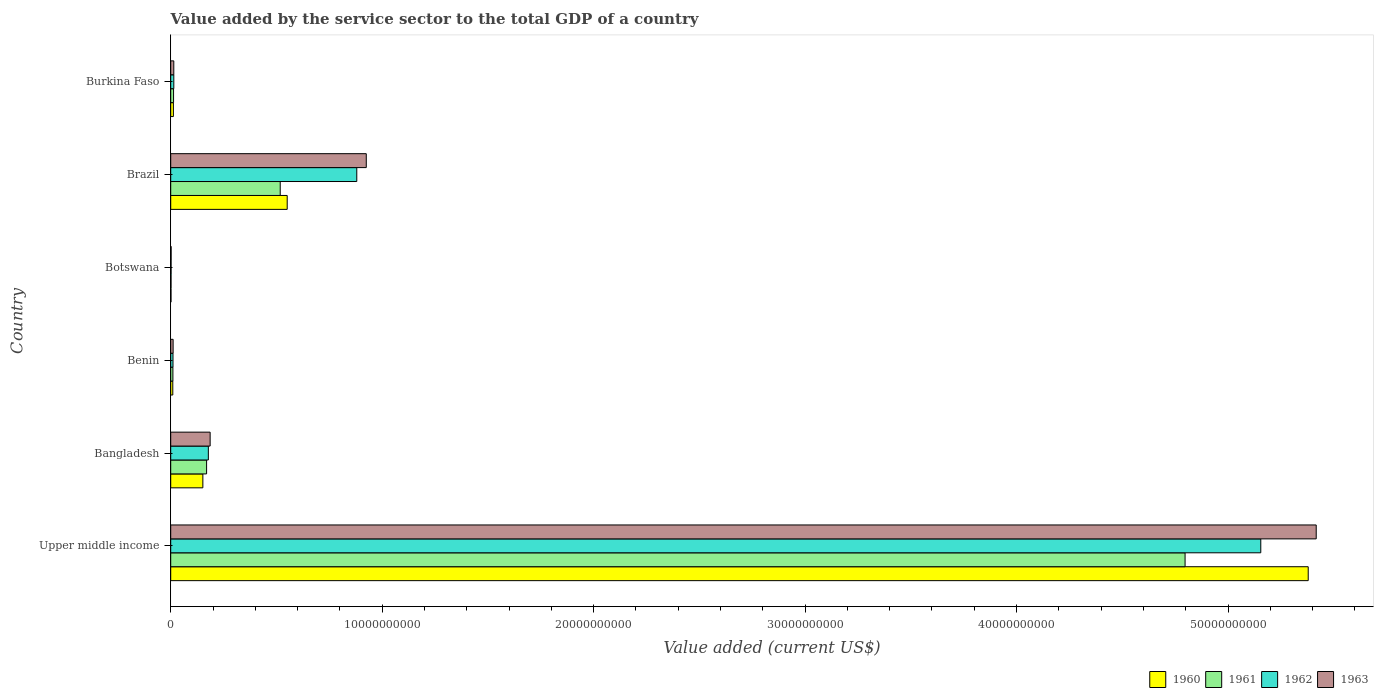How many different coloured bars are there?
Keep it short and to the point. 4. How many groups of bars are there?
Your response must be concise. 6. Are the number of bars per tick equal to the number of legend labels?
Your response must be concise. Yes. Are the number of bars on each tick of the Y-axis equal?
Offer a very short reply. Yes. What is the value added by the service sector to the total GDP in 1960 in Botswana?
Your answer should be compact. 1.31e+07. Across all countries, what is the maximum value added by the service sector to the total GDP in 1961?
Give a very brief answer. 4.80e+1. Across all countries, what is the minimum value added by the service sector to the total GDP in 1963?
Provide a short and direct response. 1.93e+07. In which country was the value added by the service sector to the total GDP in 1961 maximum?
Provide a succinct answer. Upper middle income. In which country was the value added by the service sector to the total GDP in 1961 minimum?
Provide a succinct answer. Botswana. What is the total value added by the service sector to the total GDP in 1961 in the graph?
Offer a terse response. 5.51e+1. What is the difference between the value added by the service sector to the total GDP in 1961 in Bangladesh and that in Benin?
Provide a short and direct response. 1.59e+09. What is the difference between the value added by the service sector to the total GDP in 1963 in Botswana and the value added by the service sector to the total GDP in 1962 in Burkina Faso?
Offer a very short reply. -1.27e+08. What is the average value added by the service sector to the total GDP in 1960 per country?
Offer a very short reply. 1.02e+1. What is the difference between the value added by the service sector to the total GDP in 1960 and value added by the service sector to the total GDP in 1963 in Botswana?
Make the answer very short. -6.14e+06. In how many countries, is the value added by the service sector to the total GDP in 1961 greater than 38000000000 US$?
Your answer should be compact. 1. What is the ratio of the value added by the service sector to the total GDP in 1963 in Benin to that in Burkina Faso?
Ensure brevity in your answer.  0.78. Is the value added by the service sector to the total GDP in 1963 in Brazil less than that in Burkina Faso?
Make the answer very short. No. Is the difference between the value added by the service sector to the total GDP in 1960 in Bangladesh and Burkina Faso greater than the difference between the value added by the service sector to the total GDP in 1963 in Bangladesh and Burkina Faso?
Ensure brevity in your answer.  No. What is the difference between the highest and the second highest value added by the service sector to the total GDP in 1960?
Your answer should be compact. 4.83e+1. What is the difference between the highest and the lowest value added by the service sector to the total GDP in 1961?
Give a very brief answer. 4.80e+1. In how many countries, is the value added by the service sector to the total GDP in 1961 greater than the average value added by the service sector to the total GDP in 1961 taken over all countries?
Your answer should be very brief. 1. Is the sum of the value added by the service sector to the total GDP in 1960 in Botswana and Upper middle income greater than the maximum value added by the service sector to the total GDP in 1963 across all countries?
Provide a short and direct response. No. What does the 4th bar from the top in Burkina Faso represents?
Give a very brief answer. 1960. How many bars are there?
Give a very brief answer. 24. Are the values on the major ticks of X-axis written in scientific E-notation?
Ensure brevity in your answer.  No. Where does the legend appear in the graph?
Make the answer very short. Bottom right. How many legend labels are there?
Provide a succinct answer. 4. How are the legend labels stacked?
Ensure brevity in your answer.  Horizontal. What is the title of the graph?
Ensure brevity in your answer.  Value added by the service sector to the total GDP of a country. Does "1989" appear as one of the legend labels in the graph?
Provide a succinct answer. No. What is the label or title of the X-axis?
Your answer should be compact. Value added (current US$). What is the label or title of the Y-axis?
Provide a short and direct response. Country. What is the Value added (current US$) of 1960 in Upper middle income?
Offer a very short reply. 5.38e+1. What is the Value added (current US$) in 1961 in Upper middle income?
Your answer should be very brief. 4.80e+1. What is the Value added (current US$) of 1962 in Upper middle income?
Provide a succinct answer. 5.16e+1. What is the Value added (current US$) in 1963 in Upper middle income?
Your answer should be very brief. 5.42e+1. What is the Value added (current US$) in 1960 in Bangladesh?
Your answer should be very brief. 1.52e+09. What is the Value added (current US$) in 1961 in Bangladesh?
Offer a very short reply. 1.70e+09. What is the Value added (current US$) in 1962 in Bangladesh?
Ensure brevity in your answer.  1.78e+09. What is the Value added (current US$) in 1963 in Bangladesh?
Your response must be concise. 1.86e+09. What is the Value added (current US$) of 1960 in Benin?
Your answer should be compact. 9.87e+07. What is the Value added (current US$) in 1961 in Benin?
Provide a succinct answer. 1.04e+08. What is the Value added (current US$) in 1962 in Benin?
Offer a terse response. 1.08e+08. What is the Value added (current US$) of 1963 in Benin?
Ensure brevity in your answer.  1.14e+08. What is the Value added (current US$) in 1960 in Botswana?
Keep it short and to the point. 1.31e+07. What is the Value added (current US$) of 1961 in Botswana?
Give a very brief answer. 1.51e+07. What is the Value added (current US$) of 1962 in Botswana?
Make the answer very short. 1.73e+07. What is the Value added (current US$) of 1963 in Botswana?
Your response must be concise. 1.93e+07. What is the Value added (current US$) in 1960 in Brazil?
Make the answer very short. 5.51e+09. What is the Value added (current US$) of 1961 in Brazil?
Your answer should be very brief. 5.18e+09. What is the Value added (current US$) in 1962 in Brazil?
Your answer should be very brief. 8.80e+09. What is the Value added (current US$) of 1963 in Brazil?
Give a very brief answer. 9.25e+09. What is the Value added (current US$) in 1960 in Burkina Faso?
Ensure brevity in your answer.  1.26e+08. What is the Value added (current US$) in 1961 in Burkina Faso?
Offer a terse response. 1.35e+08. What is the Value added (current US$) of 1962 in Burkina Faso?
Ensure brevity in your answer.  1.47e+08. What is the Value added (current US$) in 1963 in Burkina Faso?
Your response must be concise. 1.45e+08. Across all countries, what is the maximum Value added (current US$) of 1960?
Make the answer very short. 5.38e+1. Across all countries, what is the maximum Value added (current US$) in 1961?
Provide a short and direct response. 4.80e+1. Across all countries, what is the maximum Value added (current US$) of 1962?
Provide a short and direct response. 5.16e+1. Across all countries, what is the maximum Value added (current US$) of 1963?
Your answer should be compact. 5.42e+1. Across all countries, what is the minimum Value added (current US$) of 1960?
Make the answer very short. 1.31e+07. Across all countries, what is the minimum Value added (current US$) of 1961?
Provide a succinct answer. 1.51e+07. Across all countries, what is the minimum Value added (current US$) of 1962?
Ensure brevity in your answer.  1.73e+07. Across all countries, what is the minimum Value added (current US$) in 1963?
Offer a terse response. 1.93e+07. What is the total Value added (current US$) of 1960 in the graph?
Offer a terse response. 6.11e+1. What is the total Value added (current US$) of 1961 in the graph?
Keep it short and to the point. 5.51e+1. What is the total Value added (current US$) of 1962 in the graph?
Make the answer very short. 6.24e+1. What is the total Value added (current US$) in 1963 in the graph?
Keep it short and to the point. 6.56e+1. What is the difference between the Value added (current US$) of 1960 in Upper middle income and that in Bangladesh?
Offer a very short reply. 5.23e+1. What is the difference between the Value added (current US$) of 1961 in Upper middle income and that in Bangladesh?
Give a very brief answer. 4.63e+1. What is the difference between the Value added (current US$) of 1962 in Upper middle income and that in Bangladesh?
Your answer should be compact. 4.98e+1. What is the difference between the Value added (current US$) of 1963 in Upper middle income and that in Bangladesh?
Provide a short and direct response. 5.23e+1. What is the difference between the Value added (current US$) in 1960 in Upper middle income and that in Benin?
Your answer should be compact. 5.37e+1. What is the difference between the Value added (current US$) of 1961 in Upper middle income and that in Benin?
Your answer should be compact. 4.79e+1. What is the difference between the Value added (current US$) of 1962 in Upper middle income and that in Benin?
Keep it short and to the point. 5.14e+1. What is the difference between the Value added (current US$) of 1963 in Upper middle income and that in Benin?
Provide a succinct answer. 5.41e+1. What is the difference between the Value added (current US$) in 1960 in Upper middle income and that in Botswana?
Your answer should be compact. 5.38e+1. What is the difference between the Value added (current US$) of 1961 in Upper middle income and that in Botswana?
Offer a terse response. 4.80e+1. What is the difference between the Value added (current US$) in 1962 in Upper middle income and that in Botswana?
Make the answer very short. 5.15e+1. What is the difference between the Value added (current US$) of 1963 in Upper middle income and that in Botswana?
Your answer should be compact. 5.42e+1. What is the difference between the Value added (current US$) of 1960 in Upper middle income and that in Brazil?
Ensure brevity in your answer.  4.83e+1. What is the difference between the Value added (current US$) of 1961 in Upper middle income and that in Brazil?
Provide a succinct answer. 4.28e+1. What is the difference between the Value added (current US$) of 1962 in Upper middle income and that in Brazil?
Provide a succinct answer. 4.28e+1. What is the difference between the Value added (current US$) in 1963 in Upper middle income and that in Brazil?
Offer a terse response. 4.49e+1. What is the difference between the Value added (current US$) of 1960 in Upper middle income and that in Burkina Faso?
Offer a very short reply. 5.37e+1. What is the difference between the Value added (current US$) in 1961 in Upper middle income and that in Burkina Faso?
Offer a terse response. 4.78e+1. What is the difference between the Value added (current US$) in 1962 in Upper middle income and that in Burkina Faso?
Your answer should be compact. 5.14e+1. What is the difference between the Value added (current US$) of 1963 in Upper middle income and that in Burkina Faso?
Your answer should be very brief. 5.40e+1. What is the difference between the Value added (current US$) of 1960 in Bangladesh and that in Benin?
Your answer should be compact. 1.42e+09. What is the difference between the Value added (current US$) of 1961 in Bangladesh and that in Benin?
Provide a short and direct response. 1.59e+09. What is the difference between the Value added (current US$) in 1962 in Bangladesh and that in Benin?
Make the answer very short. 1.67e+09. What is the difference between the Value added (current US$) in 1963 in Bangladesh and that in Benin?
Give a very brief answer. 1.75e+09. What is the difference between the Value added (current US$) of 1960 in Bangladesh and that in Botswana?
Your response must be concise. 1.51e+09. What is the difference between the Value added (current US$) of 1961 in Bangladesh and that in Botswana?
Make the answer very short. 1.68e+09. What is the difference between the Value added (current US$) of 1962 in Bangladesh and that in Botswana?
Make the answer very short. 1.76e+09. What is the difference between the Value added (current US$) of 1963 in Bangladesh and that in Botswana?
Offer a terse response. 1.85e+09. What is the difference between the Value added (current US$) of 1960 in Bangladesh and that in Brazil?
Offer a very short reply. -3.99e+09. What is the difference between the Value added (current US$) in 1961 in Bangladesh and that in Brazil?
Your answer should be compact. -3.48e+09. What is the difference between the Value added (current US$) in 1962 in Bangladesh and that in Brazil?
Your answer should be very brief. -7.02e+09. What is the difference between the Value added (current US$) of 1963 in Bangladesh and that in Brazil?
Provide a short and direct response. -7.38e+09. What is the difference between the Value added (current US$) of 1960 in Bangladesh and that in Burkina Faso?
Ensure brevity in your answer.  1.39e+09. What is the difference between the Value added (current US$) of 1961 in Bangladesh and that in Burkina Faso?
Give a very brief answer. 1.56e+09. What is the difference between the Value added (current US$) in 1962 in Bangladesh and that in Burkina Faso?
Provide a succinct answer. 1.63e+09. What is the difference between the Value added (current US$) in 1963 in Bangladesh and that in Burkina Faso?
Your answer should be compact. 1.72e+09. What is the difference between the Value added (current US$) of 1960 in Benin and that in Botswana?
Make the answer very short. 8.55e+07. What is the difference between the Value added (current US$) of 1961 in Benin and that in Botswana?
Offer a very short reply. 8.86e+07. What is the difference between the Value added (current US$) of 1962 in Benin and that in Botswana?
Give a very brief answer. 9.03e+07. What is the difference between the Value added (current US$) of 1963 in Benin and that in Botswana?
Offer a terse response. 9.45e+07. What is the difference between the Value added (current US$) in 1960 in Benin and that in Brazil?
Provide a succinct answer. -5.41e+09. What is the difference between the Value added (current US$) of 1961 in Benin and that in Brazil?
Offer a terse response. -5.07e+09. What is the difference between the Value added (current US$) in 1962 in Benin and that in Brazil?
Ensure brevity in your answer.  -8.69e+09. What is the difference between the Value added (current US$) of 1963 in Benin and that in Brazil?
Offer a very short reply. -9.13e+09. What is the difference between the Value added (current US$) in 1960 in Benin and that in Burkina Faso?
Your answer should be compact. -2.78e+07. What is the difference between the Value added (current US$) of 1961 in Benin and that in Burkina Faso?
Give a very brief answer. -3.11e+07. What is the difference between the Value added (current US$) in 1962 in Benin and that in Burkina Faso?
Your answer should be very brief. -3.91e+07. What is the difference between the Value added (current US$) in 1963 in Benin and that in Burkina Faso?
Ensure brevity in your answer.  -3.15e+07. What is the difference between the Value added (current US$) in 1960 in Botswana and that in Brazil?
Provide a succinct answer. -5.50e+09. What is the difference between the Value added (current US$) in 1961 in Botswana and that in Brazil?
Offer a terse response. -5.16e+09. What is the difference between the Value added (current US$) in 1962 in Botswana and that in Brazil?
Offer a very short reply. -8.78e+09. What is the difference between the Value added (current US$) of 1963 in Botswana and that in Brazil?
Make the answer very short. -9.23e+09. What is the difference between the Value added (current US$) in 1960 in Botswana and that in Burkina Faso?
Provide a short and direct response. -1.13e+08. What is the difference between the Value added (current US$) of 1961 in Botswana and that in Burkina Faso?
Make the answer very short. -1.20e+08. What is the difference between the Value added (current US$) of 1962 in Botswana and that in Burkina Faso?
Your answer should be compact. -1.29e+08. What is the difference between the Value added (current US$) in 1963 in Botswana and that in Burkina Faso?
Make the answer very short. -1.26e+08. What is the difference between the Value added (current US$) of 1960 in Brazil and that in Burkina Faso?
Your answer should be very brief. 5.38e+09. What is the difference between the Value added (current US$) in 1961 in Brazil and that in Burkina Faso?
Keep it short and to the point. 5.04e+09. What is the difference between the Value added (current US$) in 1962 in Brazil and that in Burkina Faso?
Provide a short and direct response. 8.65e+09. What is the difference between the Value added (current US$) in 1963 in Brazil and that in Burkina Faso?
Make the answer very short. 9.10e+09. What is the difference between the Value added (current US$) of 1960 in Upper middle income and the Value added (current US$) of 1961 in Bangladesh?
Provide a short and direct response. 5.21e+1. What is the difference between the Value added (current US$) in 1960 in Upper middle income and the Value added (current US$) in 1962 in Bangladesh?
Your answer should be very brief. 5.20e+1. What is the difference between the Value added (current US$) in 1960 in Upper middle income and the Value added (current US$) in 1963 in Bangladesh?
Provide a succinct answer. 5.19e+1. What is the difference between the Value added (current US$) in 1961 in Upper middle income and the Value added (current US$) in 1962 in Bangladesh?
Give a very brief answer. 4.62e+1. What is the difference between the Value added (current US$) in 1961 in Upper middle income and the Value added (current US$) in 1963 in Bangladesh?
Offer a terse response. 4.61e+1. What is the difference between the Value added (current US$) in 1962 in Upper middle income and the Value added (current US$) in 1963 in Bangladesh?
Offer a terse response. 4.97e+1. What is the difference between the Value added (current US$) in 1960 in Upper middle income and the Value added (current US$) in 1961 in Benin?
Make the answer very short. 5.37e+1. What is the difference between the Value added (current US$) of 1960 in Upper middle income and the Value added (current US$) of 1962 in Benin?
Offer a very short reply. 5.37e+1. What is the difference between the Value added (current US$) of 1960 in Upper middle income and the Value added (current US$) of 1963 in Benin?
Your answer should be very brief. 5.37e+1. What is the difference between the Value added (current US$) of 1961 in Upper middle income and the Value added (current US$) of 1962 in Benin?
Offer a very short reply. 4.79e+1. What is the difference between the Value added (current US$) of 1961 in Upper middle income and the Value added (current US$) of 1963 in Benin?
Offer a very short reply. 4.79e+1. What is the difference between the Value added (current US$) of 1962 in Upper middle income and the Value added (current US$) of 1963 in Benin?
Keep it short and to the point. 5.14e+1. What is the difference between the Value added (current US$) of 1960 in Upper middle income and the Value added (current US$) of 1961 in Botswana?
Provide a succinct answer. 5.38e+1. What is the difference between the Value added (current US$) of 1960 in Upper middle income and the Value added (current US$) of 1962 in Botswana?
Make the answer very short. 5.38e+1. What is the difference between the Value added (current US$) of 1960 in Upper middle income and the Value added (current US$) of 1963 in Botswana?
Give a very brief answer. 5.38e+1. What is the difference between the Value added (current US$) of 1961 in Upper middle income and the Value added (current US$) of 1962 in Botswana?
Offer a very short reply. 4.80e+1. What is the difference between the Value added (current US$) of 1961 in Upper middle income and the Value added (current US$) of 1963 in Botswana?
Make the answer very short. 4.80e+1. What is the difference between the Value added (current US$) of 1962 in Upper middle income and the Value added (current US$) of 1963 in Botswana?
Your answer should be compact. 5.15e+1. What is the difference between the Value added (current US$) in 1960 in Upper middle income and the Value added (current US$) in 1961 in Brazil?
Your response must be concise. 4.86e+1. What is the difference between the Value added (current US$) in 1960 in Upper middle income and the Value added (current US$) in 1962 in Brazil?
Your answer should be very brief. 4.50e+1. What is the difference between the Value added (current US$) in 1960 in Upper middle income and the Value added (current US$) in 1963 in Brazil?
Offer a very short reply. 4.45e+1. What is the difference between the Value added (current US$) in 1961 in Upper middle income and the Value added (current US$) in 1962 in Brazil?
Your answer should be very brief. 3.92e+1. What is the difference between the Value added (current US$) in 1961 in Upper middle income and the Value added (current US$) in 1963 in Brazil?
Provide a short and direct response. 3.87e+1. What is the difference between the Value added (current US$) in 1962 in Upper middle income and the Value added (current US$) in 1963 in Brazil?
Offer a very short reply. 4.23e+1. What is the difference between the Value added (current US$) of 1960 in Upper middle income and the Value added (current US$) of 1961 in Burkina Faso?
Ensure brevity in your answer.  5.37e+1. What is the difference between the Value added (current US$) in 1960 in Upper middle income and the Value added (current US$) in 1962 in Burkina Faso?
Offer a very short reply. 5.36e+1. What is the difference between the Value added (current US$) in 1960 in Upper middle income and the Value added (current US$) in 1963 in Burkina Faso?
Offer a very short reply. 5.36e+1. What is the difference between the Value added (current US$) of 1961 in Upper middle income and the Value added (current US$) of 1962 in Burkina Faso?
Give a very brief answer. 4.78e+1. What is the difference between the Value added (current US$) in 1961 in Upper middle income and the Value added (current US$) in 1963 in Burkina Faso?
Your response must be concise. 4.78e+1. What is the difference between the Value added (current US$) of 1962 in Upper middle income and the Value added (current US$) of 1963 in Burkina Faso?
Your answer should be compact. 5.14e+1. What is the difference between the Value added (current US$) in 1960 in Bangladesh and the Value added (current US$) in 1961 in Benin?
Offer a very short reply. 1.42e+09. What is the difference between the Value added (current US$) of 1960 in Bangladesh and the Value added (current US$) of 1962 in Benin?
Your response must be concise. 1.41e+09. What is the difference between the Value added (current US$) in 1960 in Bangladesh and the Value added (current US$) in 1963 in Benin?
Give a very brief answer. 1.41e+09. What is the difference between the Value added (current US$) in 1961 in Bangladesh and the Value added (current US$) in 1962 in Benin?
Offer a very short reply. 1.59e+09. What is the difference between the Value added (current US$) in 1961 in Bangladesh and the Value added (current US$) in 1963 in Benin?
Offer a very short reply. 1.58e+09. What is the difference between the Value added (current US$) in 1962 in Bangladesh and the Value added (current US$) in 1963 in Benin?
Keep it short and to the point. 1.67e+09. What is the difference between the Value added (current US$) of 1960 in Bangladesh and the Value added (current US$) of 1961 in Botswana?
Provide a succinct answer. 1.50e+09. What is the difference between the Value added (current US$) of 1960 in Bangladesh and the Value added (current US$) of 1962 in Botswana?
Give a very brief answer. 1.50e+09. What is the difference between the Value added (current US$) in 1960 in Bangladesh and the Value added (current US$) in 1963 in Botswana?
Your answer should be very brief. 1.50e+09. What is the difference between the Value added (current US$) of 1961 in Bangladesh and the Value added (current US$) of 1962 in Botswana?
Ensure brevity in your answer.  1.68e+09. What is the difference between the Value added (current US$) of 1961 in Bangladesh and the Value added (current US$) of 1963 in Botswana?
Provide a succinct answer. 1.68e+09. What is the difference between the Value added (current US$) in 1962 in Bangladesh and the Value added (current US$) in 1963 in Botswana?
Offer a terse response. 1.76e+09. What is the difference between the Value added (current US$) of 1960 in Bangladesh and the Value added (current US$) of 1961 in Brazil?
Ensure brevity in your answer.  -3.66e+09. What is the difference between the Value added (current US$) in 1960 in Bangladesh and the Value added (current US$) in 1962 in Brazil?
Your answer should be compact. -7.28e+09. What is the difference between the Value added (current US$) of 1960 in Bangladesh and the Value added (current US$) of 1963 in Brazil?
Your response must be concise. -7.73e+09. What is the difference between the Value added (current US$) of 1961 in Bangladesh and the Value added (current US$) of 1962 in Brazil?
Give a very brief answer. -7.10e+09. What is the difference between the Value added (current US$) of 1961 in Bangladesh and the Value added (current US$) of 1963 in Brazil?
Give a very brief answer. -7.55e+09. What is the difference between the Value added (current US$) of 1962 in Bangladesh and the Value added (current US$) of 1963 in Brazil?
Your answer should be compact. -7.47e+09. What is the difference between the Value added (current US$) in 1960 in Bangladesh and the Value added (current US$) in 1961 in Burkina Faso?
Keep it short and to the point. 1.39e+09. What is the difference between the Value added (current US$) in 1960 in Bangladesh and the Value added (current US$) in 1962 in Burkina Faso?
Provide a succinct answer. 1.37e+09. What is the difference between the Value added (current US$) in 1960 in Bangladesh and the Value added (current US$) in 1963 in Burkina Faso?
Your answer should be very brief. 1.37e+09. What is the difference between the Value added (current US$) of 1961 in Bangladesh and the Value added (current US$) of 1962 in Burkina Faso?
Ensure brevity in your answer.  1.55e+09. What is the difference between the Value added (current US$) of 1961 in Bangladesh and the Value added (current US$) of 1963 in Burkina Faso?
Give a very brief answer. 1.55e+09. What is the difference between the Value added (current US$) of 1962 in Bangladesh and the Value added (current US$) of 1963 in Burkina Faso?
Ensure brevity in your answer.  1.63e+09. What is the difference between the Value added (current US$) of 1960 in Benin and the Value added (current US$) of 1961 in Botswana?
Provide a succinct answer. 8.36e+07. What is the difference between the Value added (current US$) in 1960 in Benin and the Value added (current US$) in 1962 in Botswana?
Your response must be concise. 8.14e+07. What is the difference between the Value added (current US$) of 1960 in Benin and the Value added (current US$) of 1963 in Botswana?
Offer a very short reply. 7.94e+07. What is the difference between the Value added (current US$) in 1961 in Benin and the Value added (current US$) in 1962 in Botswana?
Your answer should be very brief. 8.64e+07. What is the difference between the Value added (current US$) in 1961 in Benin and the Value added (current US$) in 1963 in Botswana?
Offer a terse response. 8.44e+07. What is the difference between the Value added (current US$) of 1962 in Benin and the Value added (current US$) of 1963 in Botswana?
Ensure brevity in your answer.  8.83e+07. What is the difference between the Value added (current US$) in 1960 in Benin and the Value added (current US$) in 1961 in Brazil?
Ensure brevity in your answer.  -5.08e+09. What is the difference between the Value added (current US$) of 1960 in Benin and the Value added (current US$) of 1962 in Brazil?
Make the answer very short. -8.70e+09. What is the difference between the Value added (current US$) in 1960 in Benin and the Value added (current US$) in 1963 in Brazil?
Offer a very short reply. -9.15e+09. What is the difference between the Value added (current US$) in 1961 in Benin and the Value added (current US$) in 1962 in Brazil?
Ensure brevity in your answer.  -8.70e+09. What is the difference between the Value added (current US$) in 1961 in Benin and the Value added (current US$) in 1963 in Brazil?
Provide a short and direct response. -9.14e+09. What is the difference between the Value added (current US$) in 1962 in Benin and the Value added (current US$) in 1963 in Brazil?
Give a very brief answer. -9.14e+09. What is the difference between the Value added (current US$) in 1960 in Benin and the Value added (current US$) in 1961 in Burkina Faso?
Your answer should be very brief. -3.61e+07. What is the difference between the Value added (current US$) in 1960 in Benin and the Value added (current US$) in 1962 in Burkina Faso?
Ensure brevity in your answer.  -4.81e+07. What is the difference between the Value added (current US$) of 1960 in Benin and the Value added (current US$) of 1963 in Burkina Faso?
Your answer should be very brief. -4.67e+07. What is the difference between the Value added (current US$) in 1961 in Benin and the Value added (current US$) in 1962 in Burkina Faso?
Your response must be concise. -4.30e+07. What is the difference between the Value added (current US$) of 1961 in Benin and the Value added (current US$) of 1963 in Burkina Faso?
Ensure brevity in your answer.  -4.16e+07. What is the difference between the Value added (current US$) in 1962 in Benin and the Value added (current US$) in 1963 in Burkina Faso?
Keep it short and to the point. -3.77e+07. What is the difference between the Value added (current US$) in 1960 in Botswana and the Value added (current US$) in 1961 in Brazil?
Keep it short and to the point. -5.17e+09. What is the difference between the Value added (current US$) in 1960 in Botswana and the Value added (current US$) in 1962 in Brazil?
Keep it short and to the point. -8.79e+09. What is the difference between the Value added (current US$) in 1960 in Botswana and the Value added (current US$) in 1963 in Brazil?
Ensure brevity in your answer.  -9.24e+09. What is the difference between the Value added (current US$) of 1961 in Botswana and the Value added (current US$) of 1962 in Brazil?
Give a very brief answer. -8.78e+09. What is the difference between the Value added (current US$) in 1961 in Botswana and the Value added (current US$) in 1963 in Brazil?
Your answer should be very brief. -9.23e+09. What is the difference between the Value added (current US$) of 1962 in Botswana and the Value added (current US$) of 1963 in Brazil?
Your answer should be compact. -9.23e+09. What is the difference between the Value added (current US$) in 1960 in Botswana and the Value added (current US$) in 1961 in Burkina Faso?
Ensure brevity in your answer.  -1.22e+08. What is the difference between the Value added (current US$) in 1960 in Botswana and the Value added (current US$) in 1962 in Burkina Faso?
Offer a terse response. -1.34e+08. What is the difference between the Value added (current US$) of 1960 in Botswana and the Value added (current US$) of 1963 in Burkina Faso?
Offer a very short reply. -1.32e+08. What is the difference between the Value added (current US$) of 1961 in Botswana and the Value added (current US$) of 1962 in Burkina Faso?
Your answer should be very brief. -1.32e+08. What is the difference between the Value added (current US$) of 1961 in Botswana and the Value added (current US$) of 1963 in Burkina Faso?
Ensure brevity in your answer.  -1.30e+08. What is the difference between the Value added (current US$) of 1962 in Botswana and the Value added (current US$) of 1963 in Burkina Faso?
Your answer should be compact. -1.28e+08. What is the difference between the Value added (current US$) of 1960 in Brazil and the Value added (current US$) of 1961 in Burkina Faso?
Ensure brevity in your answer.  5.37e+09. What is the difference between the Value added (current US$) in 1960 in Brazil and the Value added (current US$) in 1962 in Burkina Faso?
Ensure brevity in your answer.  5.36e+09. What is the difference between the Value added (current US$) in 1960 in Brazil and the Value added (current US$) in 1963 in Burkina Faso?
Give a very brief answer. 5.36e+09. What is the difference between the Value added (current US$) in 1961 in Brazil and the Value added (current US$) in 1962 in Burkina Faso?
Make the answer very short. 5.03e+09. What is the difference between the Value added (current US$) of 1961 in Brazil and the Value added (current US$) of 1963 in Burkina Faso?
Your answer should be very brief. 5.03e+09. What is the difference between the Value added (current US$) of 1962 in Brazil and the Value added (current US$) of 1963 in Burkina Faso?
Give a very brief answer. 8.65e+09. What is the average Value added (current US$) of 1960 per country?
Offer a very short reply. 1.02e+1. What is the average Value added (current US$) in 1961 per country?
Your answer should be very brief. 9.18e+09. What is the average Value added (current US$) of 1962 per country?
Offer a terse response. 1.04e+1. What is the average Value added (current US$) in 1963 per country?
Give a very brief answer. 1.09e+1. What is the difference between the Value added (current US$) of 1960 and Value added (current US$) of 1961 in Upper middle income?
Your answer should be very brief. 5.82e+09. What is the difference between the Value added (current US$) of 1960 and Value added (current US$) of 1962 in Upper middle income?
Keep it short and to the point. 2.24e+09. What is the difference between the Value added (current US$) of 1960 and Value added (current US$) of 1963 in Upper middle income?
Ensure brevity in your answer.  -3.78e+08. What is the difference between the Value added (current US$) in 1961 and Value added (current US$) in 1962 in Upper middle income?
Offer a terse response. -3.58e+09. What is the difference between the Value added (current US$) of 1961 and Value added (current US$) of 1963 in Upper middle income?
Offer a very short reply. -6.20e+09. What is the difference between the Value added (current US$) in 1962 and Value added (current US$) in 1963 in Upper middle income?
Give a very brief answer. -2.62e+09. What is the difference between the Value added (current US$) in 1960 and Value added (current US$) in 1961 in Bangladesh?
Offer a terse response. -1.77e+08. What is the difference between the Value added (current US$) in 1960 and Value added (current US$) in 1962 in Bangladesh?
Keep it short and to the point. -2.60e+08. What is the difference between the Value added (current US$) in 1960 and Value added (current US$) in 1963 in Bangladesh?
Give a very brief answer. -3.45e+08. What is the difference between the Value added (current US$) in 1961 and Value added (current US$) in 1962 in Bangladesh?
Offer a very short reply. -8.27e+07. What is the difference between the Value added (current US$) of 1961 and Value added (current US$) of 1963 in Bangladesh?
Offer a terse response. -1.68e+08. What is the difference between the Value added (current US$) of 1962 and Value added (current US$) of 1963 in Bangladesh?
Offer a terse response. -8.50e+07. What is the difference between the Value added (current US$) of 1960 and Value added (current US$) of 1961 in Benin?
Offer a terse response. -5.02e+06. What is the difference between the Value added (current US$) in 1960 and Value added (current US$) in 1962 in Benin?
Provide a short and direct response. -8.92e+06. What is the difference between the Value added (current US$) of 1960 and Value added (current US$) of 1963 in Benin?
Offer a terse response. -1.51e+07. What is the difference between the Value added (current US$) of 1961 and Value added (current US$) of 1962 in Benin?
Provide a succinct answer. -3.90e+06. What is the difference between the Value added (current US$) in 1961 and Value added (current US$) in 1963 in Benin?
Offer a terse response. -1.01e+07. What is the difference between the Value added (current US$) of 1962 and Value added (current US$) of 1963 in Benin?
Your answer should be compact. -6.21e+06. What is the difference between the Value added (current US$) in 1960 and Value added (current US$) in 1961 in Botswana?
Your answer should be compact. -1.99e+06. What is the difference between the Value added (current US$) of 1960 and Value added (current US$) of 1962 in Botswana?
Keep it short and to the point. -4.17e+06. What is the difference between the Value added (current US$) in 1960 and Value added (current US$) in 1963 in Botswana?
Ensure brevity in your answer.  -6.14e+06. What is the difference between the Value added (current US$) of 1961 and Value added (current US$) of 1962 in Botswana?
Offer a terse response. -2.18e+06. What is the difference between the Value added (current US$) of 1961 and Value added (current US$) of 1963 in Botswana?
Provide a short and direct response. -4.15e+06. What is the difference between the Value added (current US$) in 1962 and Value added (current US$) in 1963 in Botswana?
Provide a succinct answer. -1.97e+06. What is the difference between the Value added (current US$) in 1960 and Value added (current US$) in 1961 in Brazil?
Provide a succinct answer. 3.31e+08. What is the difference between the Value added (current US$) of 1960 and Value added (current US$) of 1962 in Brazil?
Your answer should be compact. -3.29e+09. What is the difference between the Value added (current US$) in 1960 and Value added (current US$) in 1963 in Brazil?
Your response must be concise. -3.74e+09. What is the difference between the Value added (current US$) of 1961 and Value added (current US$) of 1962 in Brazil?
Provide a short and direct response. -3.62e+09. What is the difference between the Value added (current US$) of 1961 and Value added (current US$) of 1963 in Brazil?
Your response must be concise. -4.07e+09. What is the difference between the Value added (current US$) of 1962 and Value added (current US$) of 1963 in Brazil?
Keep it short and to the point. -4.49e+08. What is the difference between the Value added (current US$) in 1960 and Value added (current US$) in 1961 in Burkina Faso?
Your answer should be compact. -8.32e+06. What is the difference between the Value added (current US$) in 1960 and Value added (current US$) in 1962 in Burkina Faso?
Offer a terse response. -2.03e+07. What is the difference between the Value added (current US$) of 1960 and Value added (current US$) of 1963 in Burkina Faso?
Your response must be concise. -1.89e+07. What is the difference between the Value added (current US$) of 1961 and Value added (current US$) of 1962 in Burkina Faso?
Offer a terse response. -1.19e+07. What is the difference between the Value added (current US$) of 1961 and Value added (current US$) of 1963 in Burkina Faso?
Provide a short and direct response. -1.06e+07. What is the difference between the Value added (current US$) of 1962 and Value added (current US$) of 1963 in Burkina Faso?
Your answer should be very brief. 1.38e+06. What is the ratio of the Value added (current US$) in 1960 in Upper middle income to that in Bangladesh?
Give a very brief answer. 35.4. What is the ratio of the Value added (current US$) in 1961 in Upper middle income to that in Bangladesh?
Provide a succinct answer. 28.27. What is the ratio of the Value added (current US$) in 1962 in Upper middle income to that in Bangladesh?
Keep it short and to the point. 28.97. What is the ratio of the Value added (current US$) in 1963 in Upper middle income to that in Bangladesh?
Ensure brevity in your answer.  29.06. What is the ratio of the Value added (current US$) of 1960 in Upper middle income to that in Benin?
Keep it short and to the point. 545.27. What is the ratio of the Value added (current US$) in 1961 in Upper middle income to that in Benin?
Give a very brief answer. 462.69. What is the ratio of the Value added (current US$) in 1962 in Upper middle income to that in Benin?
Provide a short and direct response. 479.2. What is the ratio of the Value added (current US$) of 1963 in Upper middle income to that in Benin?
Your answer should be very brief. 476.07. What is the ratio of the Value added (current US$) in 1960 in Upper middle income to that in Botswana?
Your response must be concise. 4102.17. What is the ratio of the Value added (current US$) in 1961 in Upper middle income to that in Botswana?
Offer a very short reply. 3175.77. What is the ratio of the Value added (current US$) of 1962 in Upper middle income to that in Botswana?
Keep it short and to the point. 2982.43. What is the ratio of the Value added (current US$) in 1963 in Upper middle income to that in Botswana?
Your answer should be compact. 2813.98. What is the ratio of the Value added (current US$) of 1960 in Upper middle income to that in Brazil?
Keep it short and to the point. 9.76. What is the ratio of the Value added (current US$) in 1961 in Upper middle income to that in Brazil?
Your answer should be compact. 9.26. What is the ratio of the Value added (current US$) of 1962 in Upper middle income to that in Brazil?
Make the answer very short. 5.86. What is the ratio of the Value added (current US$) of 1963 in Upper middle income to that in Brazil?
Give a very brief answer. 5.86. What is the ratio of the Value added (current US$) in 1960 in Upper middle income to that in Burkina Faso?
Your answer should be compact. 425.42. What is the ratio of the Value added (current US$) in 1961 in Upper middle income to that in Burkina Faso?
Make the answer very short. 355.95. What is the ratio of the Value added (current US$) of 1962 in Upper middle income to that in Burkina Faso?
Your answer should be compact. 351.38. What is the ratio of the Value added (current US$) in 1963 in Upper middle income to that in Burkina Faso?
Keep it short and to the point. 372.76. What is the ratio of the Value added (current US$) of 1960 in Bangladesh to that in Benin?
Offer a terse response. 15.41. What is the ratio of the Value added (current US$) in 1961 in Bangladesh to that in Benin?
Your answer should be very brief. 16.36. What is the ratio of the Value added (current US$) in 1962 in Bangladesh to that in Benin?
Offer a very short reply. 16.54. What is the ratio of the Value added (current US$) of 1963 in Bangladesh to that in Benin?
Provide a succinct answer. 16.38. What is the ratio of the Value added (current US$) of 1960 in Bangladesh to that in Botswana?
Offer a terse response. 115.9. What is the ratio of the Value added (current US$) in 1961 in Bangladesh to that in Botswana?
Give a very brief answer. 112.32. What is the ratio of the Value added (current US$) of 1962 in Bangladesh to that in Botswana?
Give a very brief answer. 102.95. What is the ratio of the Value added (current US$) of 1963 in Bangladesh to that in Botswana?
Offer a terse response. 96.85. What is the ratio of the Value added (current US$) of 1960 in Bangladesh to that in Brazil?
Offer a very short reply. 0.28. What is the ratio of the Value added (current US$) of 1961 in Bangladesh to that in Brazil?
Your answer should be very brief. 0.33. What is the ratio of the Value added (current US$) in 1962 in Bangladesh to that in Brazil?
Your answer should be very brief. 0.2. What is the ratio of the Value added (current US$) of 1963 in Bangladesh to that in Brazil?
Give a very brief answer. 0.2. What is the ratio of the Value added (current US$) in 1960 in Bangladesh to that in Burkina Faso?
Keep it short and to the point. 12.02. What is the ratio of the Value added (current US$) in 1961 in Bangladesh to that in Burkina Faso?
Ensure brevity in your answer.  12.59. What is the ratio of the Value added (current US$) of 1962 in Bangladesh to that in Burkina Faso?
Provide a short and direct response. 12.13. What is the ratio of the Value added (current US$) of 1963 in Bangladesh to that in Burkina Faso?
Provide a succinct answer. 12.83. What is the ratio of the Value added (current US$) in 1960 in Benin to that in Botswana?
Give a very brief answer. 7.52. What is the ratio of the Value added (current US$) of 1961 in Benin to that in Botswana?
Give a very brief answer. 6.86. What is the ratio of the Value added (current US$) of 1962 in Benin to that in Botswana?
Keep it short and to the point. 6.22. What is the ratio of the Value added (current US$) in 1963 in Benin to that in Botswana?
Offer a very short reply. 5.91. What is the ratio of the Value added (current US$) of 1960 in Benin to that in Brazil?
Provide a succinct answer. 0.02. What is the ratio of the Value added (current US$) in 1962 in Benin to that in Brazil?
Offer a very short reply. 0.01. What is the ratio of the Value added (current US$) of 1963 in Benin to that in Brazil?
Provide a short and direct response. 0.01. What is the ratio of the Value added (current US$) in 1960 in Benin to that in Burkina Faso?
Make the answer very short. 0.78. What is the ratio of the Value added (current US$) of 1961 in Benin to that in Burkina Faso?
Keep it short and to the point. 0.77. What is the ratio of the Value added (current US$) of 1962 in Benin to that in Burkina Faso?
Your answer should be compact. 0.73. What is the ratio of the Value added (current US$) in 1963 in Benin to that in Burkina Faso?
Give a very brief answer. 0.78. What is the ratio of the Value added (current US$) of 1960 in Botswana to that in Brazil?
Make the answer very short. 0. What is the ratio of the Value added (current US$) in 1961 in Botswana to that in Brazil?
Give a very brief answer. 0. What is the ratio of the Value added (current US$) of 1962 in Botswana to that in Brazil?
Ensure brevity in your answer.  0. What is the ratio of the Value added (current US$) in 1963 in Botswana to that in Brazil?
Keep it short and to the point. 0. What is the ratio of the Value added (current US$) of 1960 in Botswana to that in Burkina Faso?
Your answer should be compact. 0.1. What is the ratio of the Value added (current US$) in 1961 in Botswana to that in Burkina Faso?
Provide a succinct answer. 0.11. What is the ratio of the Value added (current US$) in 1962 in Botswana to that in Burkina Faso?
Provide a succinct answer. 0.12. What is the ratio of the Value added (current US$) in 1963 in Botswana to that in Burkina Faso?
Ensure brevity in your answer.  0.13. What is the ratio of the Value added (current US$) in 1960 in Brazil to that in Burkina Faso?
Provide a succinct answer. 43.57. What is the ratio of the Value added (current US$) of 1961 in Brazil to that in Burkina Faso?
Keep it short and to the point. 38.42. What is the ratio of the Value added (current US$) in 1962 in Brazil to that in Burkina Faso?
Provide a succinct answer. 59.98. What is the ratio of the Value added (current US$) of 1963 in Brazil to that in Burkina Faso?
Your answer should be very brief. 63.64. What is the difference between the highest and the second highest Value added (current US$) of 1960?
Your answer should be very brief. 4.83e+1. What is the difference between the highest and the second highest Value added (current US$) in 1961?
Provide a short and direct response. 4.28e+1. What is the difference between the highest and the second highest Value added (current US$) of 1962?
Make the answer very short. 4.28e+1. What is the difference between the highest and the second highest Value added (current US$) in 1963?
Make the answer very short. 4.49e+1. What is the difference between the highest and the lowest Value added (current US$) of 1960?
Offer a very short reply. 5.38e+1. What is the difference between the highest and the lowest Value added (current US$) of 1961?
Ensure brevity in your answer.  4.80e+1. What is the difference between the highest and the lowest Value added (current US$) of 1962?
Your answer should be very brief. 5.15e+1. What is the difference between the highest and the lowest Value added (current US$) in 1963?
Provide a short and direct response. 5.42e+1. 